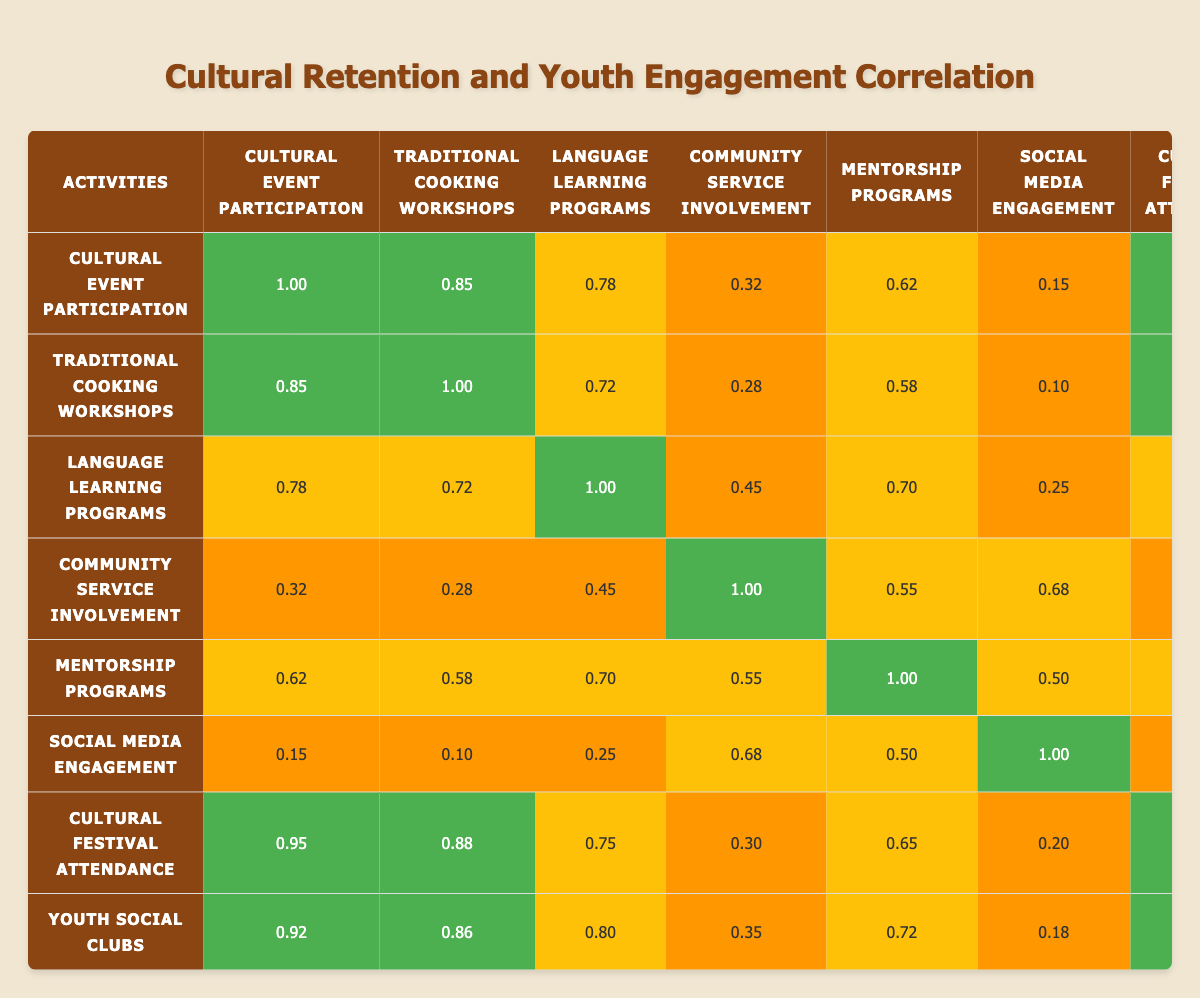What is the correlation between Cultural Event Participation and Cultural Festival Attendance? The table shows that the correlation value between Cultural Event Participation and Cultural Festival Attendance is 0.95, which indicates a strong positive relationship between these two variables.
Answer: 0.95 Which activity has the highest correlation with Youth Social Clubs? From the table, the highest correlation value with Youth Social Clubs is 0.90, which is with Cultural Festival Attendance.
Answer: 0.90 Is there a low correlation between Social Media Engagement and Cultural Event Participation? The correlation value between Social Media Engagement and Cultural Event Participation is 0.15. Since this value is low (close to 0), it confirms that there is indeed a low correlation.
Answer: Yes What is the average correlation value of Traditional Cooking Workshops with other activities? The correlation values for Traditional Cooking Workshops with other activities are 0.85, 1.00, 0.72, 0.28, 0.58, 0.10, 0.88, and 0.86. To find the average, sum these values (5.27) and divide by 7 (the number of relationships), which results in an average of approximately 0.75.
Answer: 0.75 Which two activities show the strongest correlation according to the table? The table indicates that Cultural Festival Attendance and Cultural Event Participation show the strongest correlation at 0.95, followed closely by Traditional Cooking Workshops with Cultural Festival Attendance at 0.88.
Answer: Cultural Festival Attendance and Cultural Event Participation What is the difference between the correlation values of Language Learning Programs and Community Service Involvement? The correlation value for Language Learning Programs is 0.70, and for Community Service Involvement, it is 0.55. The difference is calculated as 0.70 - 0.55, resulting in 0.15.
Answer: 0.15 Is there a strong correlation between Community Service Involvement and Mentorship Programs? The correlation value between Community Service Involvement and Mentorship Programs is 0.55, which does indicate a moderate correlation, but it is not classified as strong according to conventional understanding.
Answer: No Which activity has the lowest correlation with Social Media Engagement? The lowest correlation with Social Media Engagement is 0.10, which is with Traditional Cooking Workshops.
Answer: 0.10 